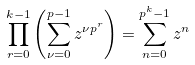<formula> <loc_0><loc_0><loc_500><loc_500>\prod _ { r = 0 } ^ { k - 1 } \left ( \sum _ { \nu = 0 } ^ { p - 1 } z ^ { \nu p ^ { r } } \right ) = \sum _ { n = 0 } ^ { p ^ { k } - 1 } z ^ { n }</formula> 